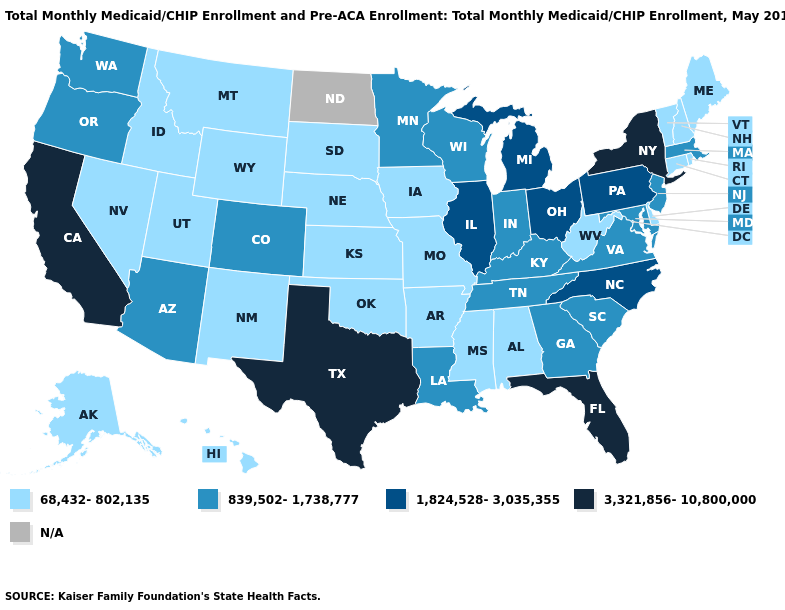What is the value of South Dakota?
Quick response, please. 68,432-802,135. Among the states that border Tennessee , which have the lowest value?
Short answer required. Alabama, Arkansas, Mississippi, Missouri. Among the states that border Tennessee , does Arkansas have the highest value?
Quick response, please. No. Is the legend a continuous bar?
Answer briefly. No. Name the states that have a value in the range 839,502-1,738,777?
Answer briefly. Arizona, Colorado, Georgia, Indiana, Kentucky, Louisiana, Maryland, Massachusetts, Minnesota, New Jersey, Oregon, South Carolina, Tennessee, Virginia, Washington, Wisconsin. Does Colorado have the lowest value in the West?
Quick response, please. No. How many symbols are there in the legend?
Keep it brief. 5. What is the value of Vermont?
Quick response, please. 68,432-802,135. Which states have the lowest value in the South?
Write a very short answer. Alabama, Arkansas, Delaware, Mississippi, Oklahoma, West Virginia. Name the states that have a value in the range 68,432-802,135?
Be succinct. Alabama, Alaska, Arkansas, Connecticut, Delaware, Hawaii, Idaho, Iowa, Kansas, Maine, Mississippi, Missouri, Montana, Nebraska, Nevada, New Hampshire, New Mexico, Oklahoma, Rhode Island, South Dakota, Utah, Vermont, West Virginia, Wyoming. What is the value of South Dakota?
Answer briefly. 68,432-802,135. What is the value of Vermont?
Write a very short answer. 68,432-802,135. Name the states that have a value in the range 1,824,528-3,035,355?
Be succinct. Illinois, Michigan, North Carolina, Ohio, Pennsylvania. What is the highest value in states that border Tennessee?
Answer briefly. 1,824,528-3,035,355. 